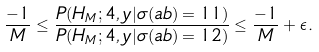<formula> <loc_0><loc_0><loc_500><loc_500>\frac { - 1 } { M } \leq \frac { P ( H _ { M } ; 4 , y | \sigma ( a b ) = 1 1 ) } { P ( H _ { M } ; 4 , y | \sigma ( a b ) = 1 2 ) } \leq \frac { - 1 } { M } + \epsilon .</formula> 